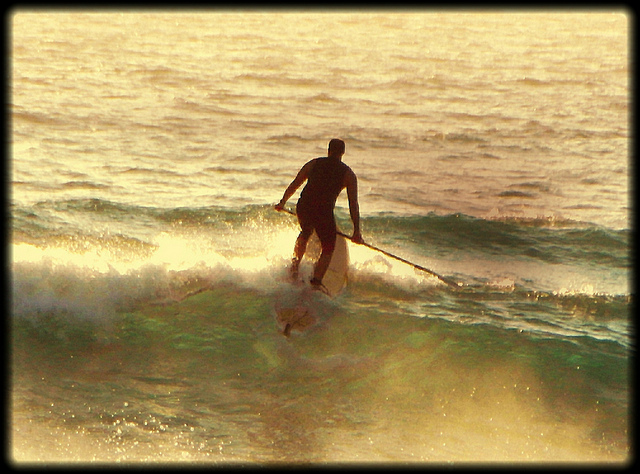How would you describe the waves the man is surfing on? The waves the man is riding appear to be relatively calm and gentle. They are not very high or powerful, making them ideal for a smooth paddleboarding experience. 